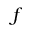Convert formula to latex. <formula><loc_0><loc_0><loc_500><loc_500>f</formula> 